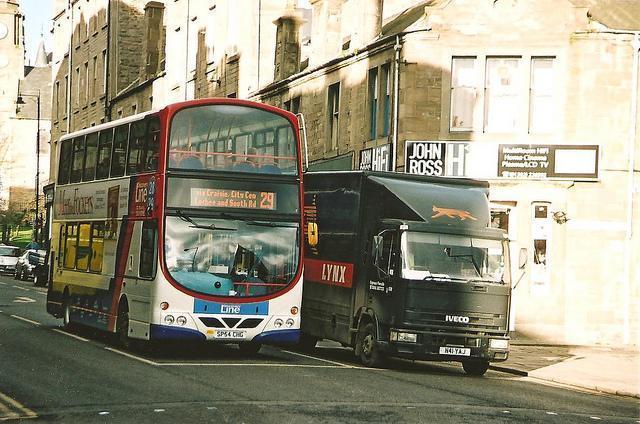How many levels does the bus have?
Give a very brief answer. 2. How many laptops are there?
Give a very brief answer. 0. 